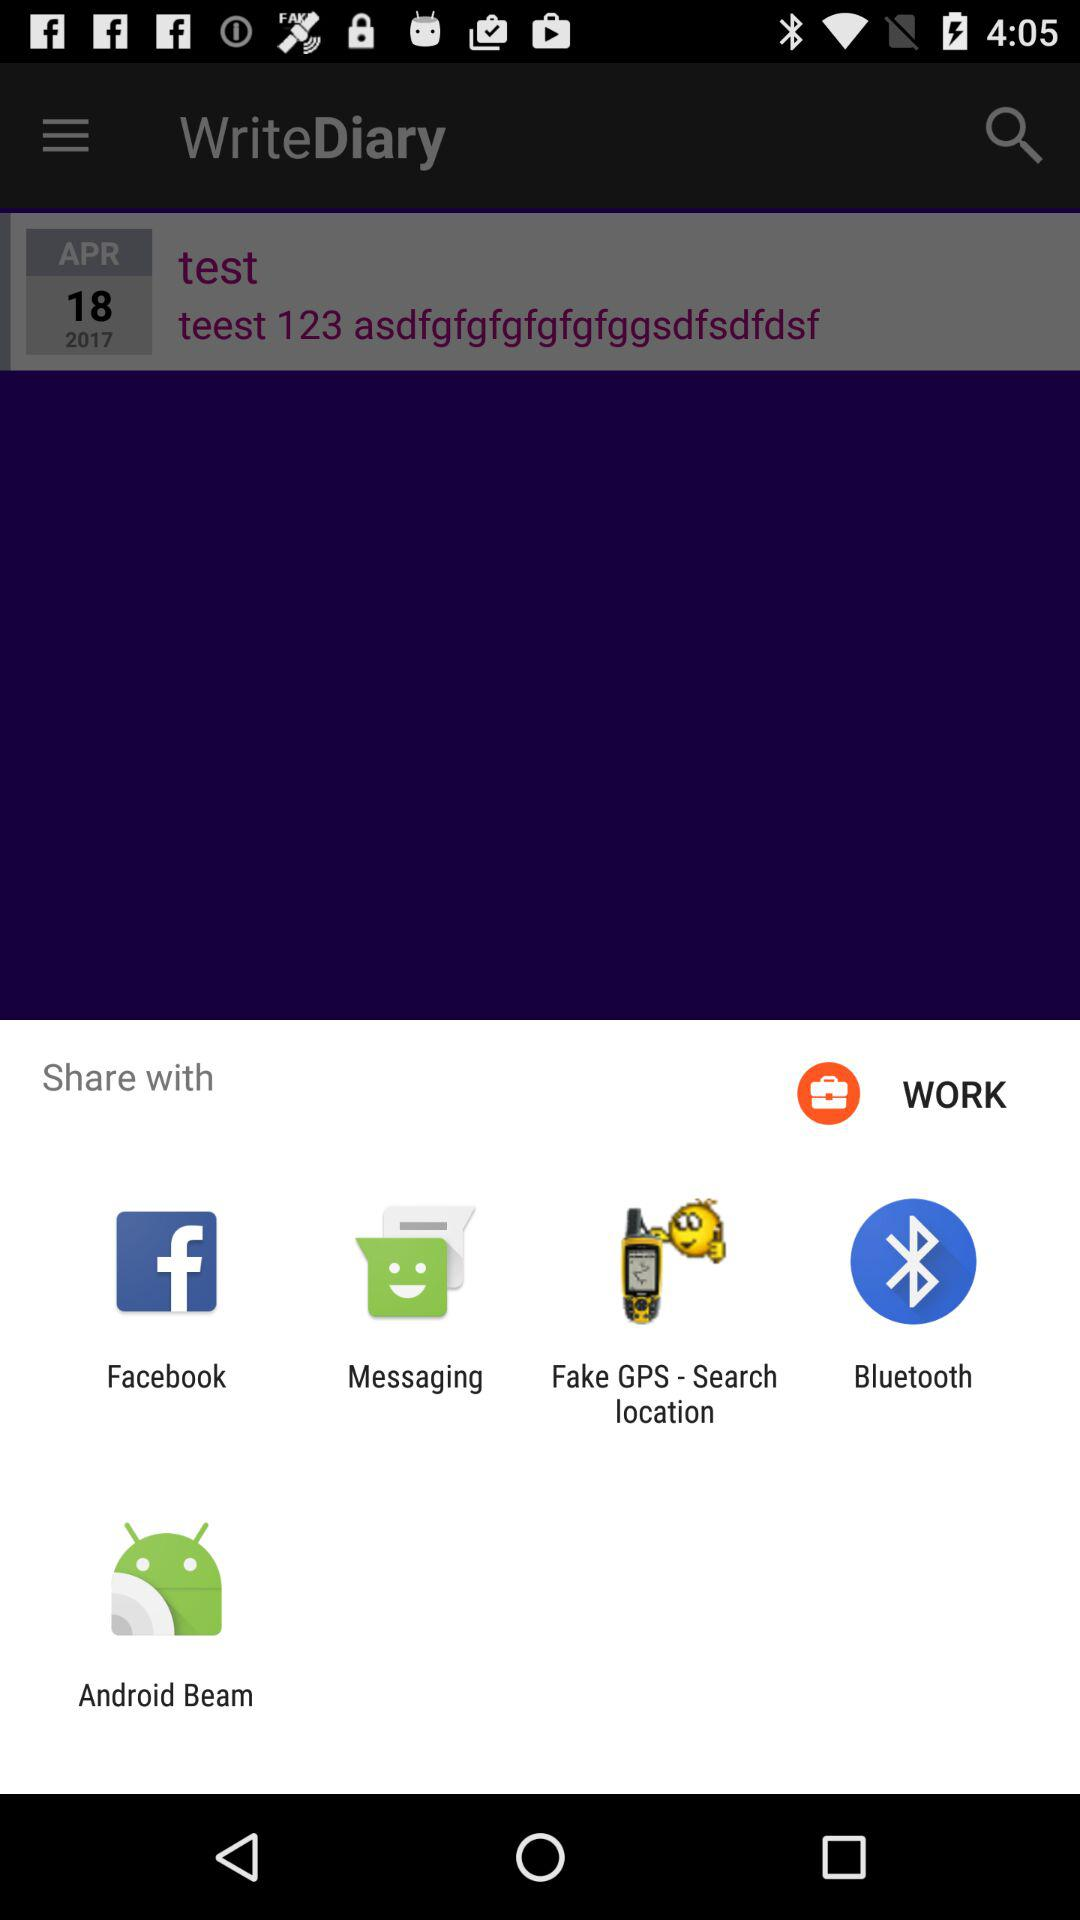Which applications can be used to share? The applications "Facebook", "Messaging", "Fake GPS - Search location", "Bluetooth" and "Android Beam" can be used to share. 